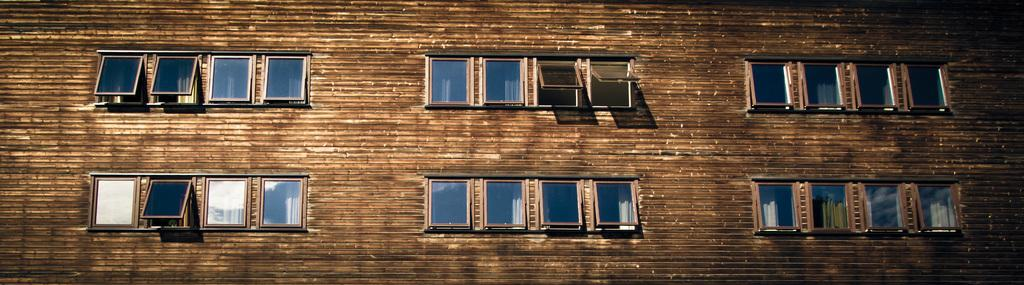What type of structure is present in the image? There is a wall in the image. What can be seen on the wall in the image? There are windows in the image. How many times does the person in the image sneeze? There is no person present in the image, so it is not possible to determine how many times they sneeze. 